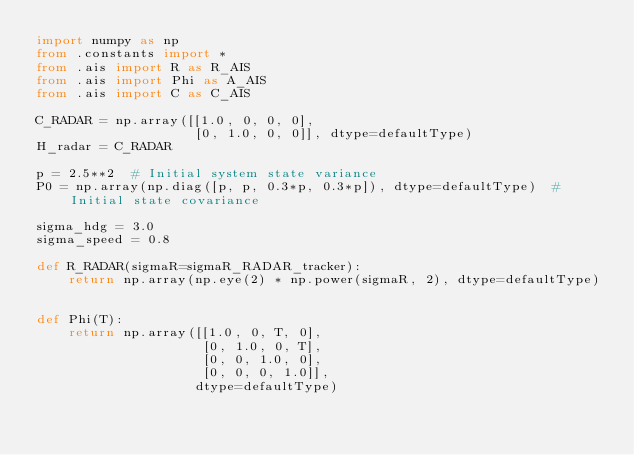Convert code to text. <code><loc_0><loc_0><loc_500><loc_500><_Python_>import numpy as np
from .constants import *
from .ais import R as R_AIS
from .ais import Phi as A_AIS
from .ais import C as C_AIS

C_RADAR = np.array([[1.0, 0, 0, 0],
                    [0, 1.0, 0, 0]], dtype=defaultType)
H_radar = C_RADAR

p = 2.5**2  # Initial system state variance
P0 = np.array(np.diag([p, p, 0.3*p, 0.3*p]), dtype=defaultType)  # Initial state covariance

sigma_hdg = 3.0
sigma_speed = 0.8

def R_RADAR(sigmaR=sigmaR_RADAR_tracker):
    return np.array(np.eye(2) * np.power(sigmaR, 2), dtype=defaultType)


def Phi(T):
    return np.array([[1.0, 0, T, 0],
                     [0, 1.0, 0, T],
                     [0, 0, 1.0, 0],
                     [0, 0, 0, 1.0]],
                    dtype=defaultType)
</code> 